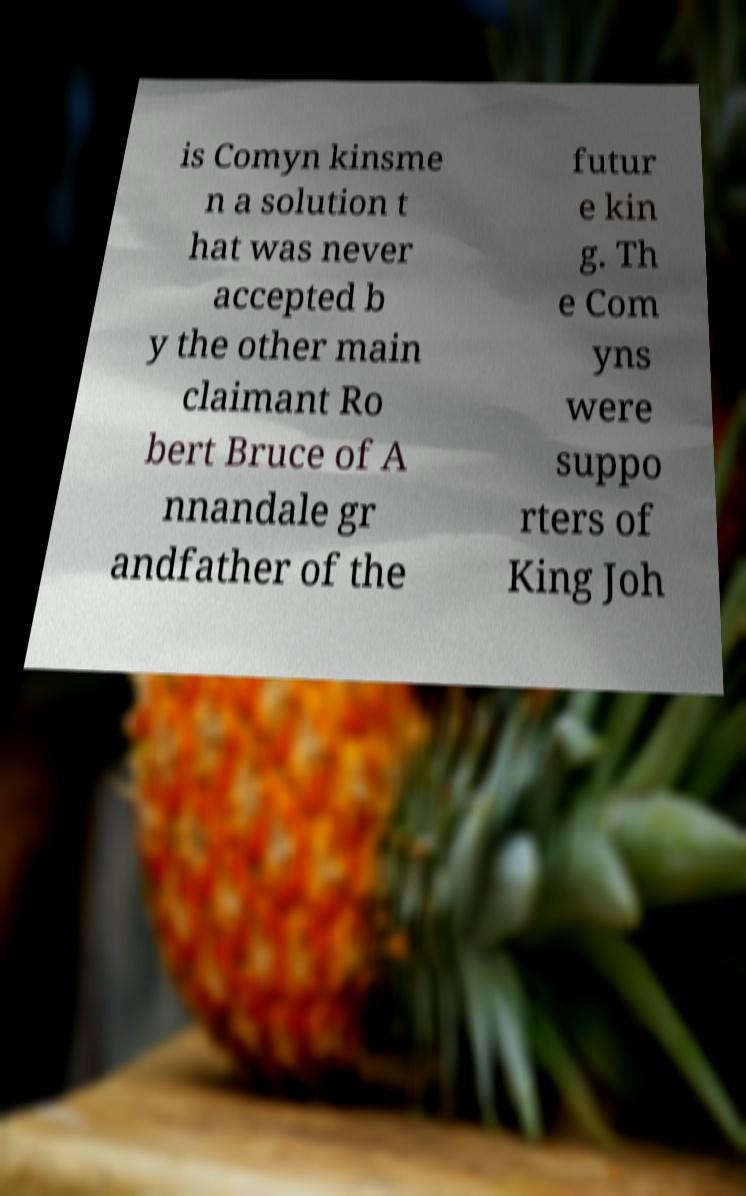Can you read and provide the text displayed in the image?This photo seems to have some interesting text. Can you extract and type it out for me? is Comyn kinsme n a solution t hat was never accepted b y the other main claimant Ro bert Bruce of A nnandale gr andfather of the futur e kin g. Th e Com yns were suppo rters of King Joh 